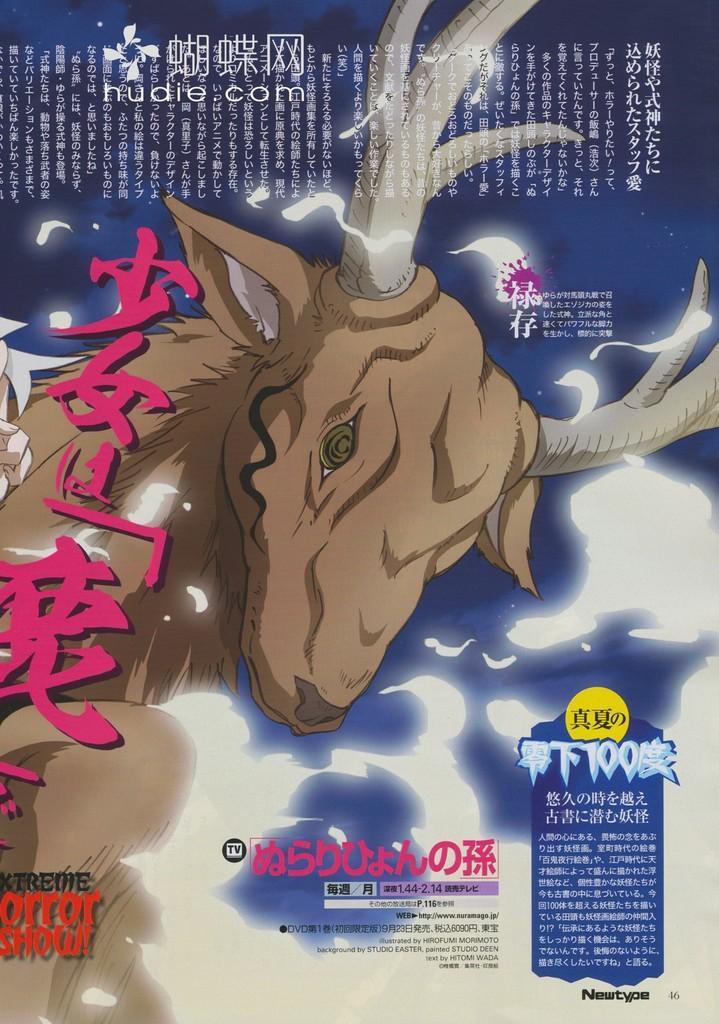Please provide a concise description of this image. In this image I can see the animated animal in brown and cream color. I can see something is written on the image and the background is in blue and white color. 